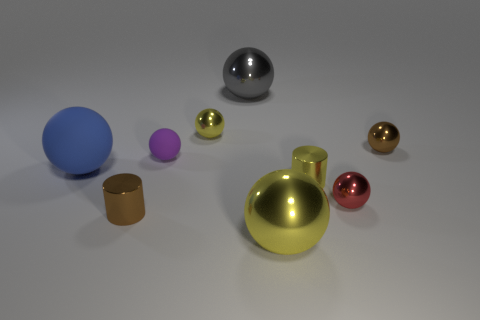Are there an equal number of gray metallic spheres on the left side of the blue object and brown metallic balls on the right side of the big gray thing?
Offer a terse response. No. There is a shiny sphere that is to the left of the big gray metal ball; is its size the same as the purple rubber sphere behind the big blue sphere?
Ensure brevity in your answer.  Yes. What is the big ball that is in front of the gray metal thing and behind the big yellow ball made of?
Offer a very short reply. Rubber. Are there fewer big spheres than big yellow objects?
Offer a very short reply. No. How big is the brown thing that is to the left of the brown thing that is behind the big blue thing?
Make the answer very short. Small. There is a small yellow thing that is in front of the yellow thing that is on the left side of the big shiny sphere in front of the big blue rubber ball; what shape is it?
Ensure brevity in your answer.  Cylinder. There is a large ball that is the same material as the big gray object; what color is it?
Provide a succinct answer. Yellow. The big object in front of the tiny brown metal thing that is to the left of the small metallic ball on the left side of the large gray metallic ball is what color?
Offer a very short reply. Yellow. What number of blocks are either big blue rubber things or yellow things?
Give a very brief answer. 0. What color is the tiny rubber sphere?
Keep it short and to the point. Purple. 